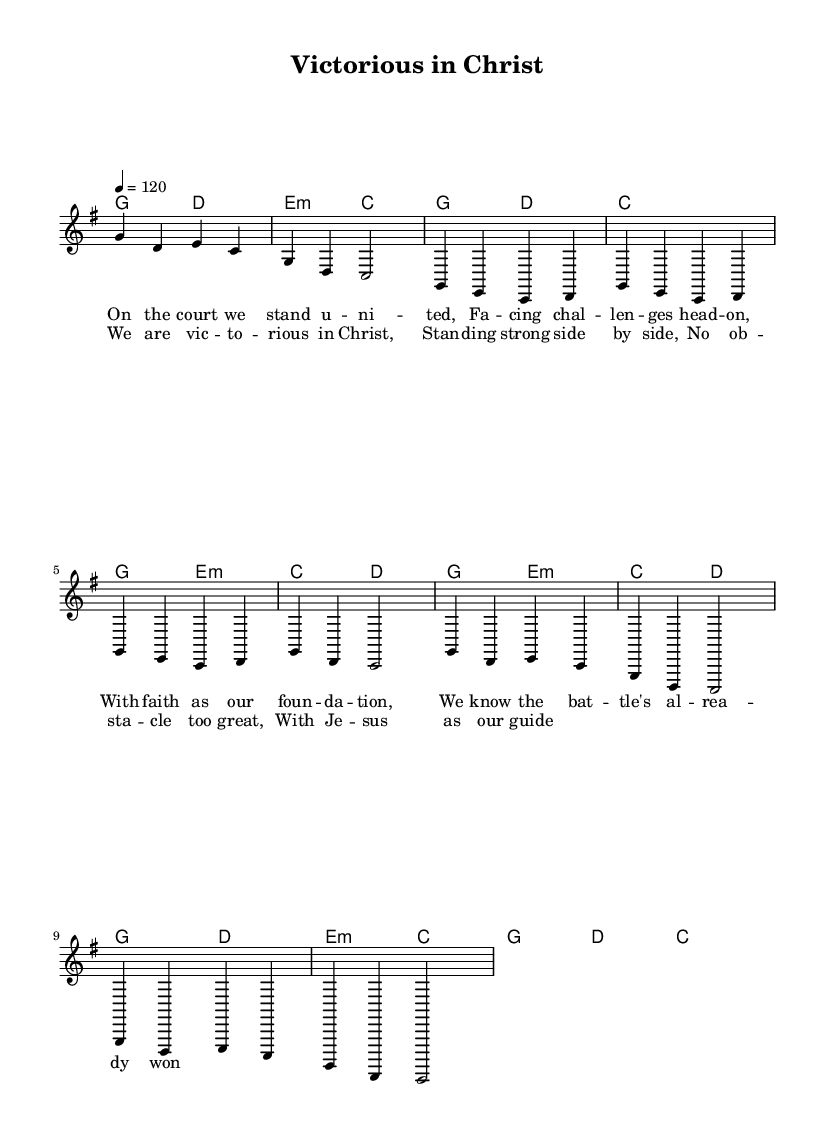What is the key signature of this music? The key signature is G major, which has one sharp (F#). This is determined by examining the note clusters at the beginning of the melody part where the 'g' note is highlighted alongside an F#.
Answer: G major What is the time signature of this music? The time signature is 4/4, indicated at the beginning of the score. This means there are four beats in a measure and a quarter note gets one beat.
Answer: 4/4 What is the tempo marking for this music? The tempo marking is 120 beats per minute, which is located at the beginning of the score. It sets the speed of the piece, allowing performers to play at a lively pace.
Answer: 120 How many measures are in the chorus? The chorus consists of four measures, which can be counted by looking at the section from the music labeled as ‘Chorus’ and counting each group of notes divided by vertical lines.
Answer: Four What is the main theme of the lyrics in this piece? The main theme revolves around victory and unity in faith, as indicated by phrases like "We are victorious in Christ" and "With Jesus as our guide." The lyrics emphasize teamwork and overcoming challenges.
Answer: Victory and unity What chords are used in the chorus? The chords used in the chorus are G, D, E minor, and C. This is derived from the chord names provided above the melody during the chorus section, which assist in playing along with the singing.
Answer: G, D, E minor, C What identity does this song promote in the context of teamwork? The song promotes unity and strength through shared faith in Christ, implying that teamwork is enhanced by spiritual belief and collective purpose as expressed in the lyrics.
Answer: Unity through faith 